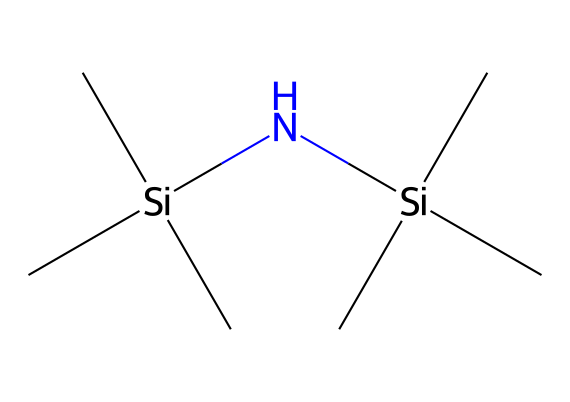What is the molecular formula of hexamethyldisilazane? The molecule contains two silicon atoms, and six carbon atoms along with one nitrogen atom and fourteen hydrogen atoms. Combining these counts gives us the molecular formula: C6H19N2Si2.
Answer: C6H19N2Si2 How many silicon atoms are present in the structure? By examining the SMILES representation, we can count the silicon (Si) symbols, which appear twice (Si appears in two different places). Therefore, there are two silicon atoms in the structure.
Answer: 2 What type of functional group is present in hexamethyldisilazane? The nitrogen atom indicates the presence of an amine group in the structure. The connectivity confirms that it’s a modified silazane.
Answer: amine How many ethyl groups are associated with the silicon atoms? Each silicon atom is bonded to three methyl groups as illustrated by the three "C" connected to each Si in the SMILES string. There are no ethyl groups present.
Answer: 0 What unique property of silanes is reflected in the structure of hexamethyldisilazane? The presence of Si-N bonds signifies that hexamethyldisilazane possesses characteristics associated with silanes, including the reactivity that arises from the silicon's ability to form multiple bonds with carbon and nitrogen.
Answer: reactivity Is hexamethyldisilazane a liquid or solid at room temperature? Based on its properties, primarily its low molecular weight and the structure's volatility, hexamethyldisilazane is generally a liquid at room temperature.
Answer: liquid 